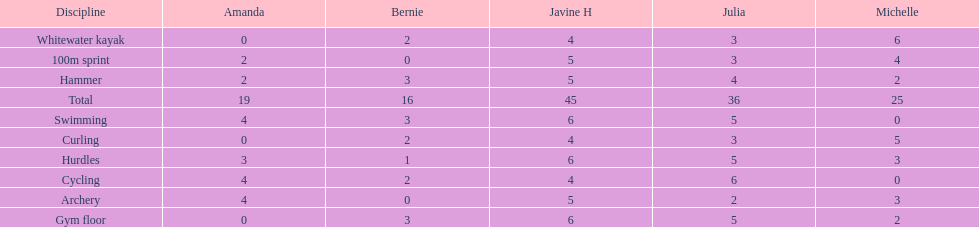What is the last discipline listed on this chart? 100m sprint. 